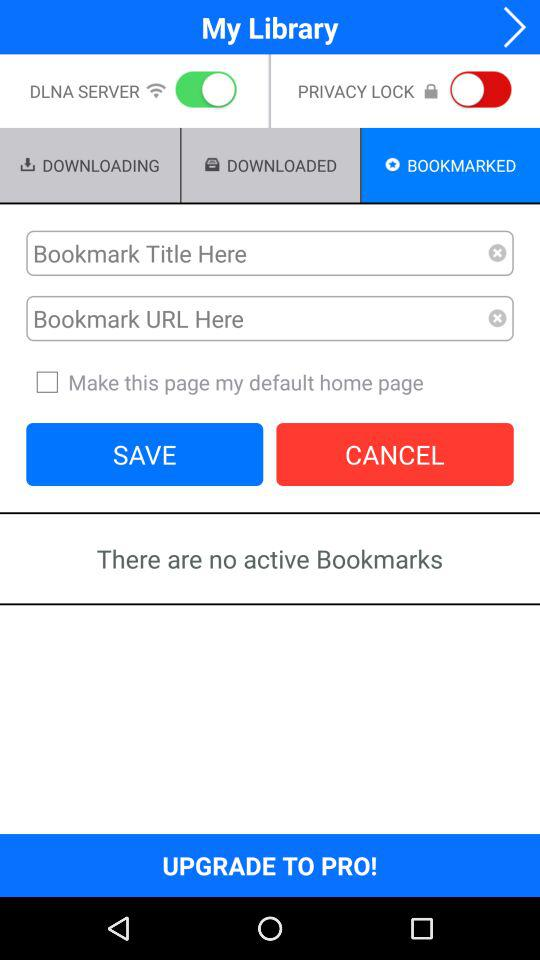Which tab is currently selected? The currently selected tab is "BOOKMARKED". 